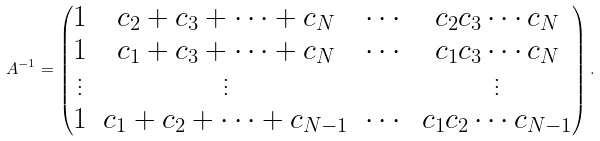Convert formula to latex. <formula><loc_0><loc_0><loc_500><loc_500>A ^ { - 1 } = \begin{pmatrix} 1 & c _ { 2 } + c _ { 3 } + \cdots + c _ { N } & \cdots & c _ { 2 } c _ { 3 } \cdots c _ { N } \\ 1 & c _ { 1 } + c _ { 3 } + \cdots + c _ { N } & \cdots & c _ { 1 } c _ { 3 } \cdots c _ { N } \\ \vdots & \vdots & & \vdots \\ 1 & c _ { 1 } + c _ { 2 } + \cdots + c _ { N - 1 } & \cdots & c _ { 1 } c _ { 2 } \cdots c _ { N - 1 } \end{pmatrix} .</formula> 